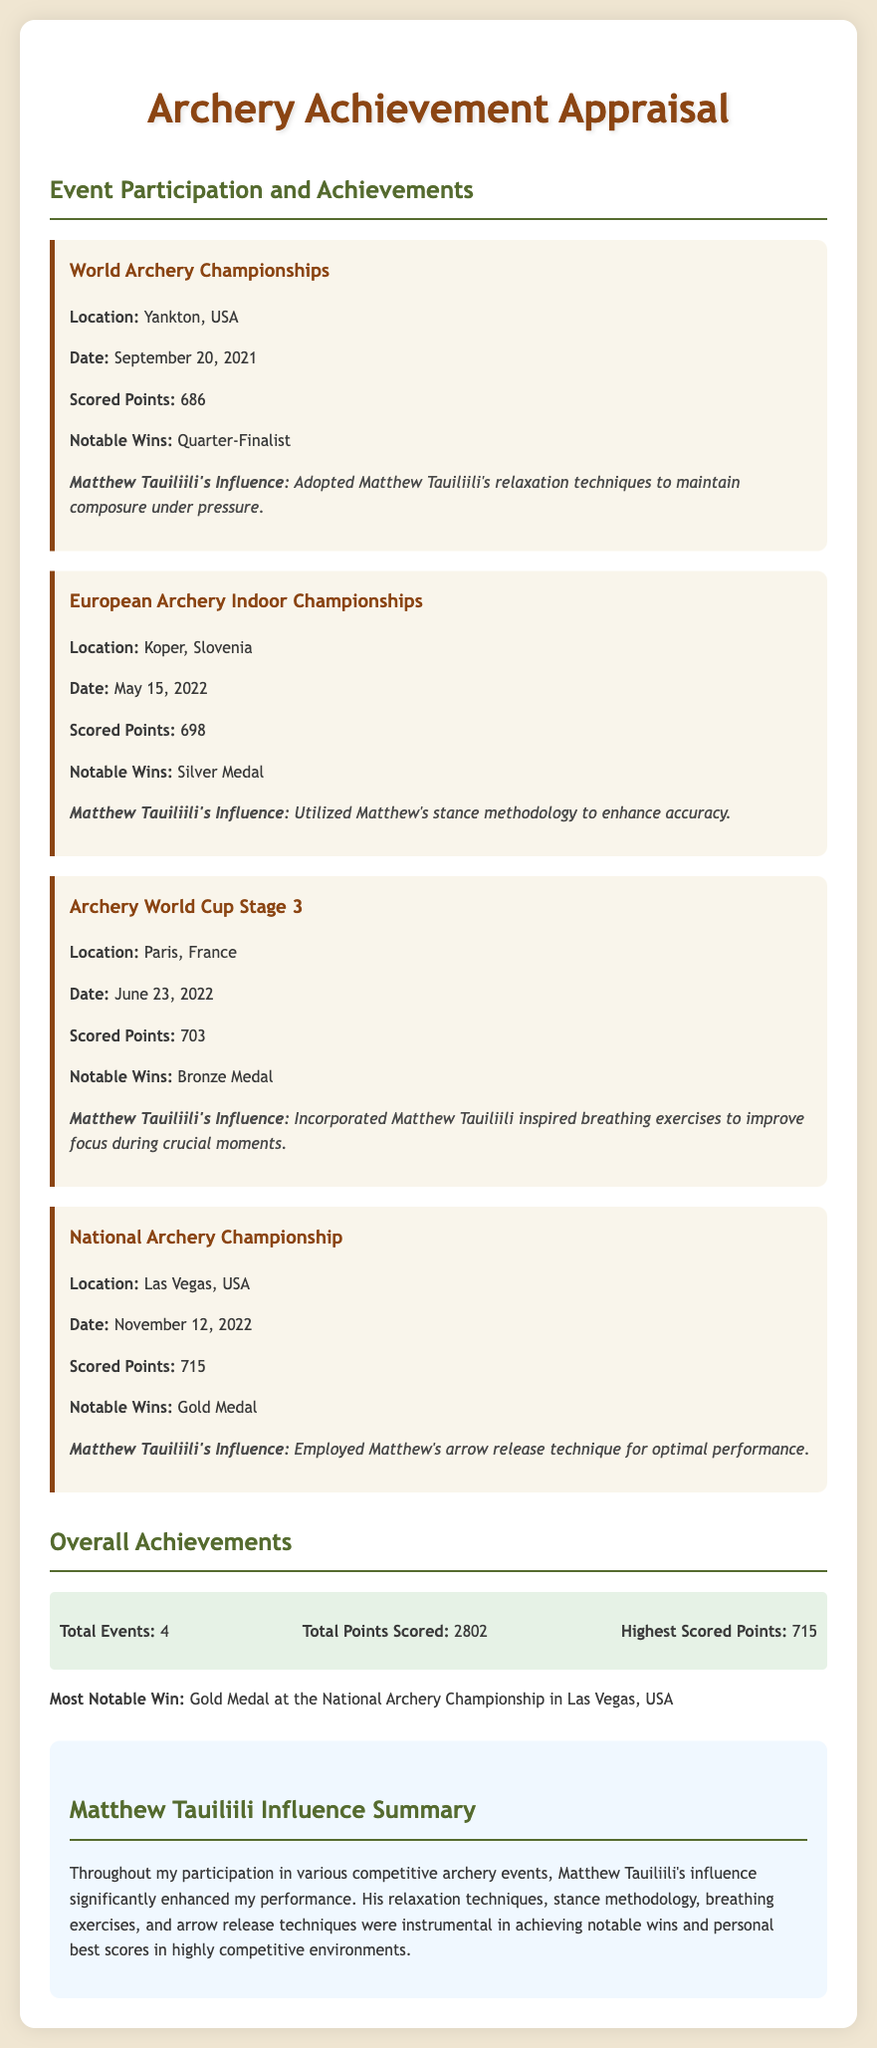What was the highest scored points? The highest scored points is stated in the overall achievements section of the document, which lists the highest point as 715.
Answer: 715 Who achieved a Silver Medal at a competition? The European Archery Indoor Championships mentions winning a Silver Medal, indicating that it was achieved at that event.
Answer: Silver Medal When did the World Archery Championships take place? The date of the World Archery Championships is explicitly mentioned in the document as September 20, 2021.
Answer: September 20, 2021 What influence did Matthew Tauiliili have at the National Archery Championship? The document states that at the National Archery Championship, Matthew's arrow release technique was employed for optimal performance.
Answer: Arrow release technique What is the total number of events participated in? The overall achievements section summarizes that a total of 4 events were attended.
Answer: 4 Which event had the most notable win? The most notable win is highlighted in the document as the Gold Medal at the National Archery Championship in Las Vegas, USA.
Answer: Gold Medal at the National Archery Championship What is the total points scored across all events? The total points scored is provided in the overall achievements section, which combines the score from all events to a total of 2802 points.
Answer: 2802 What breathing exercises were inspired by Matthew Tauiliili? The section under the Archery World Cup Stage 3 indicates that breathing exercises inspired by Matthew were used to improve focus.
Answer: Breathing exercises What was the location of the Archery World Cup Stage 3? The document specifies that the Archery World Cup Stage 3 took place in Paris, France.
Answer: Paris, France 